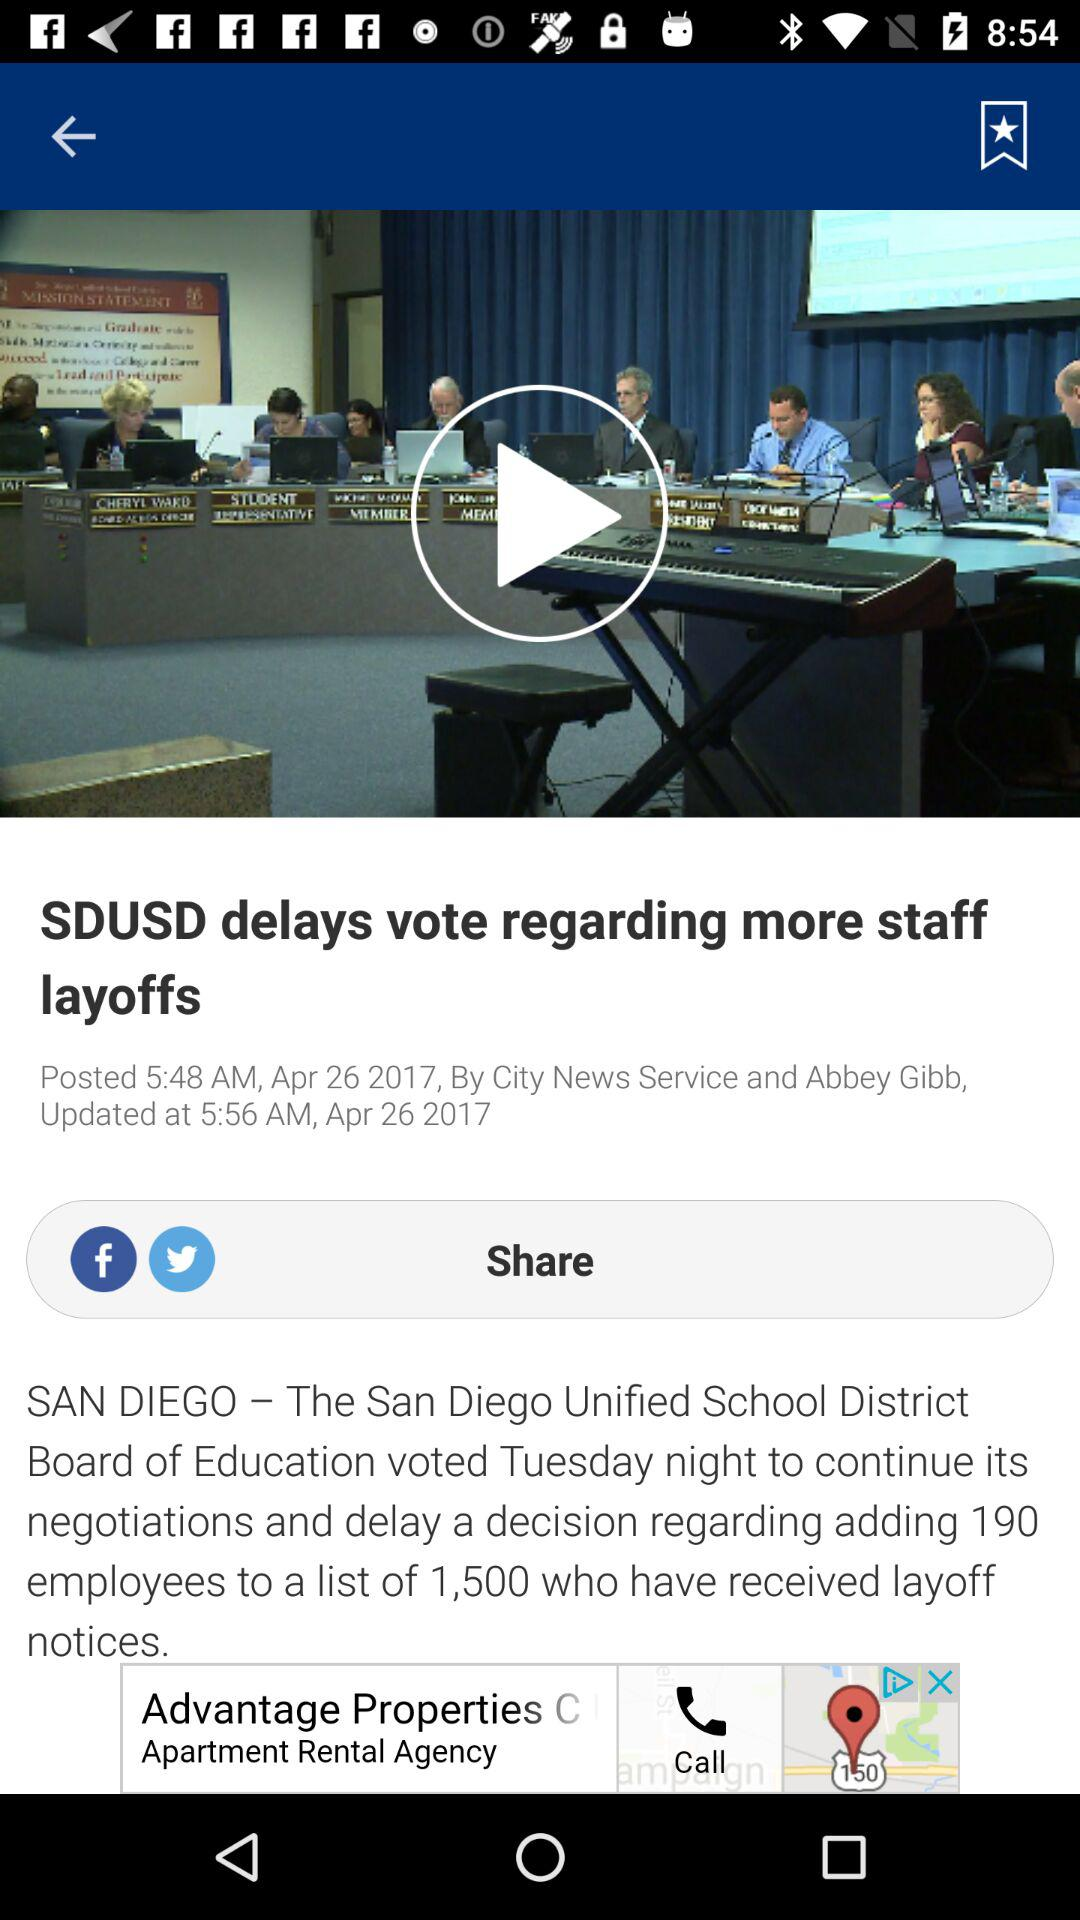What is the headline? The headline is "SDUSD delays vote regarding more staff layoffs". 